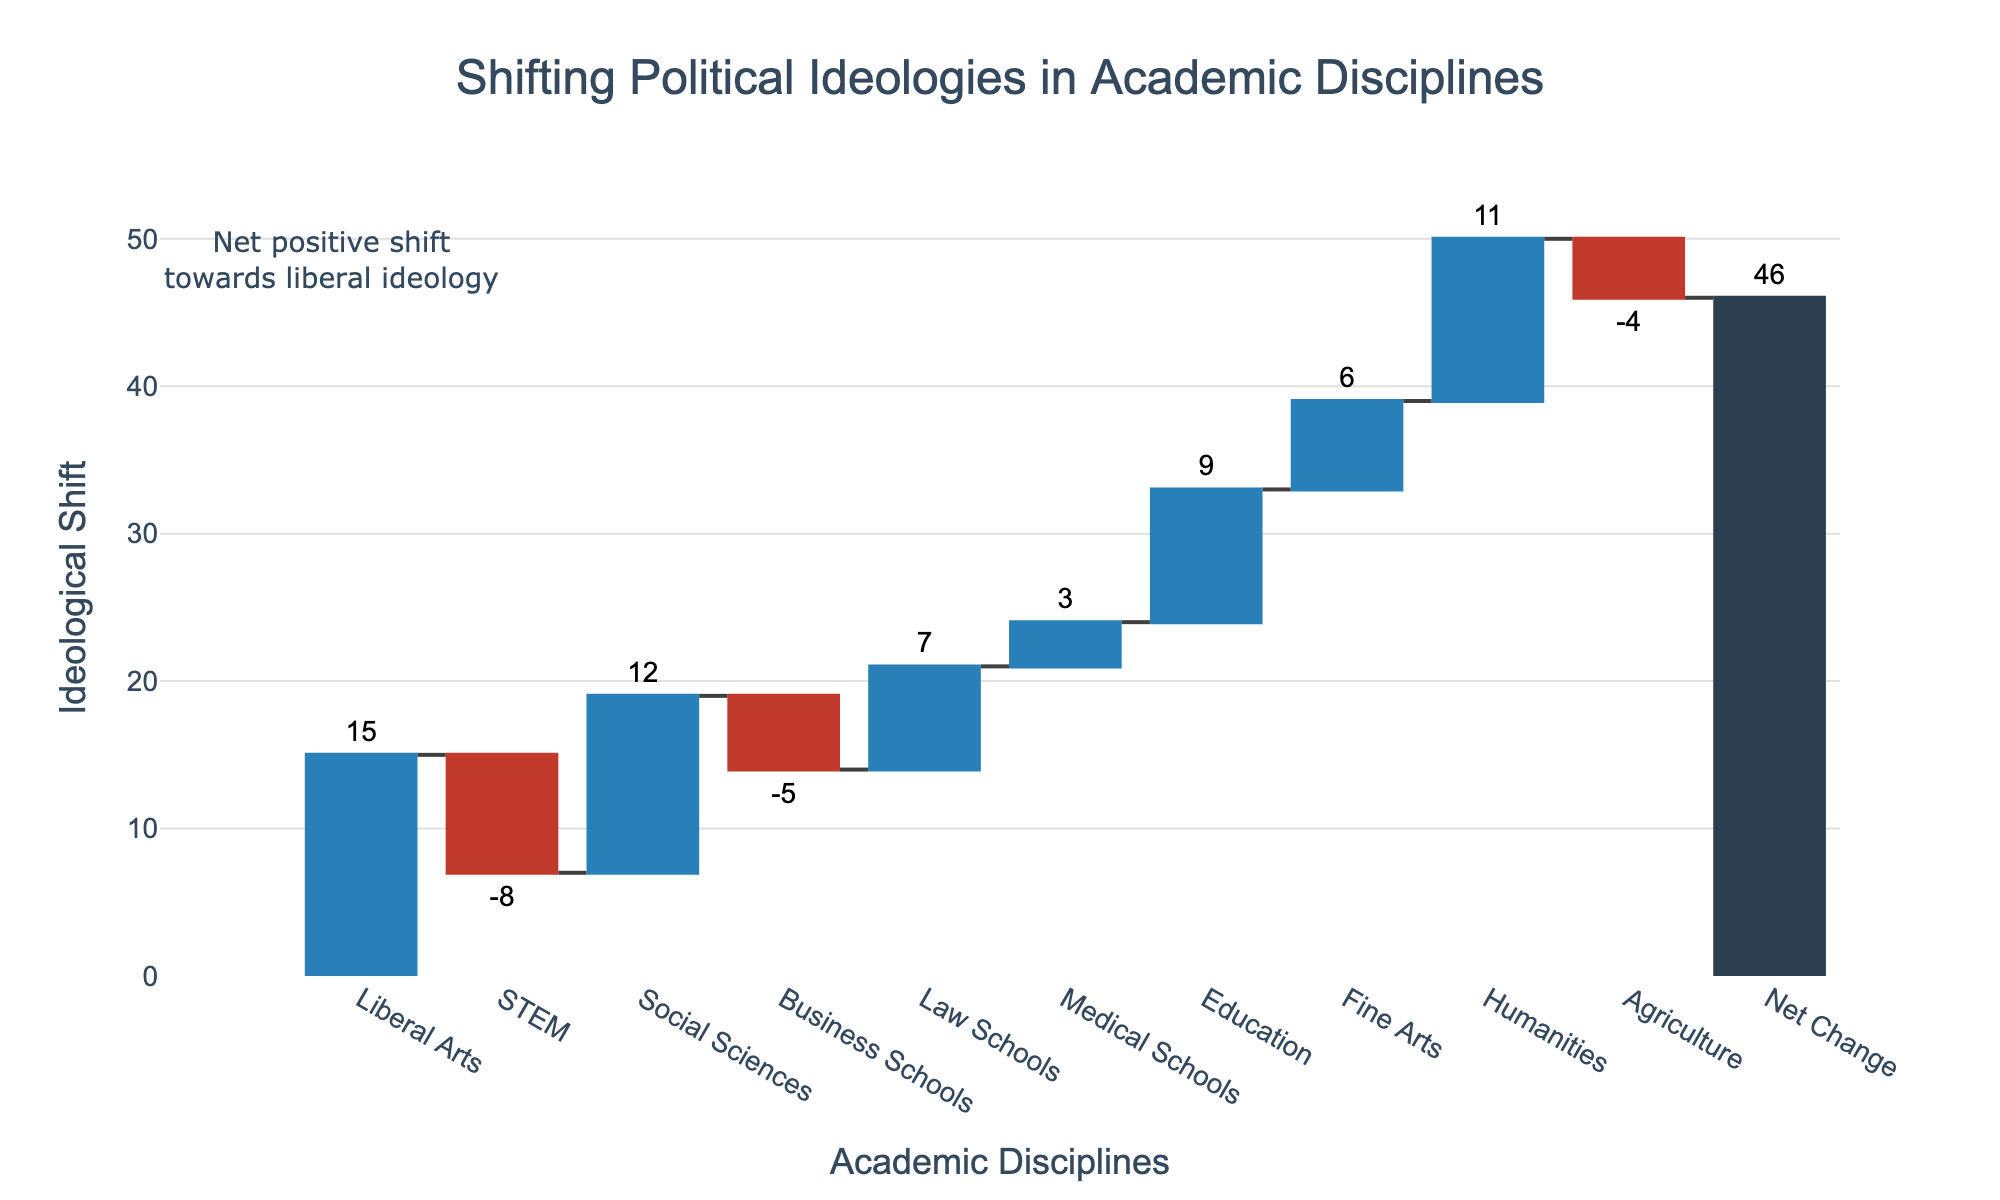What is the total ideological shift in academic disciplines? The total ideological shift is represented by the 'Net Change' bar at the end of the chart. It sums up all the individual shifts in the different disciplines. In this case, the 'Net Change' shows a value of 46.
Answer: 46 What does the color of the bars represent in this chart? The colors represent different elements: positive shifts are in blue, negative shifts are in red, and the total net change is in dark blue. This color coding helps visually distinguish between increases, decreases, and the aggregate effect.
Answer: Positive (blue), Negative (red), Total (dark blue) Which academic discipline reflects the highest positive ideological shift? By observing the height and value of the bars, the 'Liberal Arts' discipline has the highest positive shift, shown by a bar with a value of 15.
Answer: Liberal Arts What is the ideological shift value for STEM disciplines? The ideological shift for STEM disciplines is represented by a red bar and has a value of -8, indicating a negative shift.
Answer: -8 How do the shifts in Social Sciences and Business Schools compare? Social Sciences has a positive shift of 12, while Business Schools have a negative shift of -5. Social Sciences shift is more significant and positive compared to Business Schools.
Answer: Social Sciences: 12, Business Schools: -5 What is the sum of ideological shifts for the Liberal Arts, Social Sciences, and Law Schools? Summing the shifts for these disciplines: Liberal Arts (15), Social Sciences (12), and Law Schools (7) gives 15 + 12 + 7 = 34.
Answer: 34 How many disciplines show a negative ideological shift? The chart indicates that there are three disciplines with negative shifts: STEM (-8), Business Schools (-5), and Agriculture (-4).
Answer: 3 Which discipline has the smallest positive ideological shift and what is its value? By comparing the values of the positive shifts, Medical Schools have the smallest positive shift, with a value of 3.
Answer: Medical Schools, 3 If we exclude the net change, what is the average of the positive ideological shifts? Adding up all positive shifts (15 + 12 + 7 + 3 + 9 + 6 + 11) gives 63. There are 7 positive shifts, so the average is 63 / 7 = 9.
Answer: 9 What is the ideological shift in Humanities relative to STEM? Humanities have a positive shift of 11, while STEM has a negative shift of -8. The relative difference is 11 - (-8) = 19.
Answer: 19 